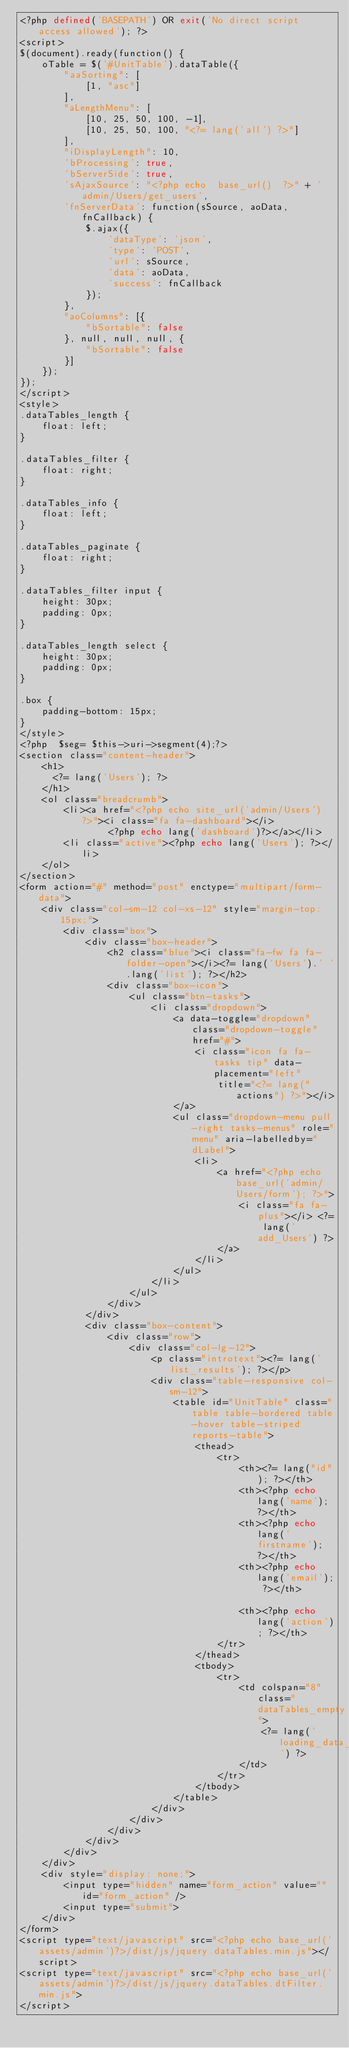<code> <loc_0><loc_0><loc_500><loc_500><_PHP_><?php defined('BASEPATH') OR exit('No direct script access allowed'); ?>
<script>
$(document).ready(function() {
    oTable = $('#UnitTable').dataTable({
        "aaSorting": [
            [1, "asc"]
        ],
        "aLengthMenu": [
            [10, 25, 50, 100, -1],
            [10, 25, 50, 100, "<?= lang('all') ?>"]
        ],
        "iDisplayLength": 10,
        'bProcessing': true,
        'bServerSide': true,
        'sAjaxSource': "<?php echo  base_url()  ?>" + 'admin/Users/get_users',
        'fnServerData': function(sSource, aoData, fnCallback) {
            $.ajax({
                'dataType': 'json',
                'type': 'POST',
                'url': sSource,
                'data': aoData,
                'success': fnCallback
            });
        },
        "aoColumns": [{
            "bSortable": false
        }, null, null, null, {
            "bSortable": false
        }]
    });
});
</script>
<style>
.dataTables_length {
    float: left;
}

.dataTables_filter {
    float: right;
}

.dataTables_info {
    float: left;
}

.dataTables_paginate {
    float: right;
}

.dataTables_filter input {
    height: 30px;
    padding: 0px;
}

.dataTables_length select {
    height: 30px;
    padding: 0px;
}

.box {
    padding-bottom: 15px;
}
</style>
<?php  $seg= $this->uri->segment(4);?>
<section class="content-header">
    <h1>
      <?= lang('Users'); ?>
    </h1>
    <ol class="breadcrumb">
        <li><a href="<?php echo site_url('admin/Users') ?>"><i class="fa fa-dashboard"></i>
                <?php echo lang('dashboard')?></a></li>
        <li class="active"><?php echo lang('Users'); ?></li>
    </ol>
</section>
<form action="#" method="post" enctype="multipart/form-data">
    <div class="col-sm-12 col-xs-12" style="margin-top: 15px;">
        <div class="box">
            <div class="box-header">
                <h2 class="blue"><i class="fa-fw fa fa-folder-open"></i><?= lang('Users').' '.lang('list'); ?></h2>
                <div class="box-icon">
                    <ul class="btn-tasks">
                        <li class="dropdown">
                            <a data-toggle="dropdown" class="dropdown-toggle" href="#">
                                <i class="icon fa fa-tasks tip" data-placement="left"
                                    title="<?= lang("actions") ?>"></i>
                            </a>
                            <ul class="dropdown-menu pull-right tasks-menus" role="menu" aria-labelledby="dLabel">
                                <li>
                                    <a href="<?php echo base_url('admin/Users/form'); ?>">
                                        <i class="fa fa-plus"></i> <?= lang('add_Users') ?>
                                    </a>
                                </li>
                            </ul>
                        </li>
                    </ul>
                </div>
            </div>
            <div class="box-content">
                <div class="row">
                    <div class="col-lg-12">
                        <p class="introtext"><?= lang('list_results'); ?></p>
                        <div class="table-responsive col-sm-12">
                            <table id="UnitTable" class="table table-bordered table-hover table-striped reports-table">
                                <thead>
                                    <tr>
                                        <th><?= lang("id"); ?></th>
                                        <th><?php echo lang('name'); ?></th>
                                        <th><?php echo lang('firstname'); ?></th>
                                        <th><?php echo lang('email'); ?></th>
                                      
                                        <th><?php echo lang('action'); ?></th>
                                    </tr>
                                </thead>
                                <tbody>
                                    <tr>
                                        <td colspan="8" class="dataTables_empty">
                                            <?= lang('loading_data_from_server') ?>
                                        </td>
                                    </tr>
                                </tbody>
                            </table>
                        </div>
                    </div>
                </div>
            </div>
        </div>
    </div>
    <div style="display: none;">
        <input type="hidden" name="form_action" value="" id="form_action" />
        <input type="submit">
    </div>
</form>
<script type="text/javascript" src="<?php echo base_url('assets/admin')?>/dist/js/jquery.dataTables.min.js"></script>
<script type="text/javascript" src="<?php echo base_url('assets/admin')?>/dist/js/jquery.dataTables.dtFilter.min.js">
</script></code> 